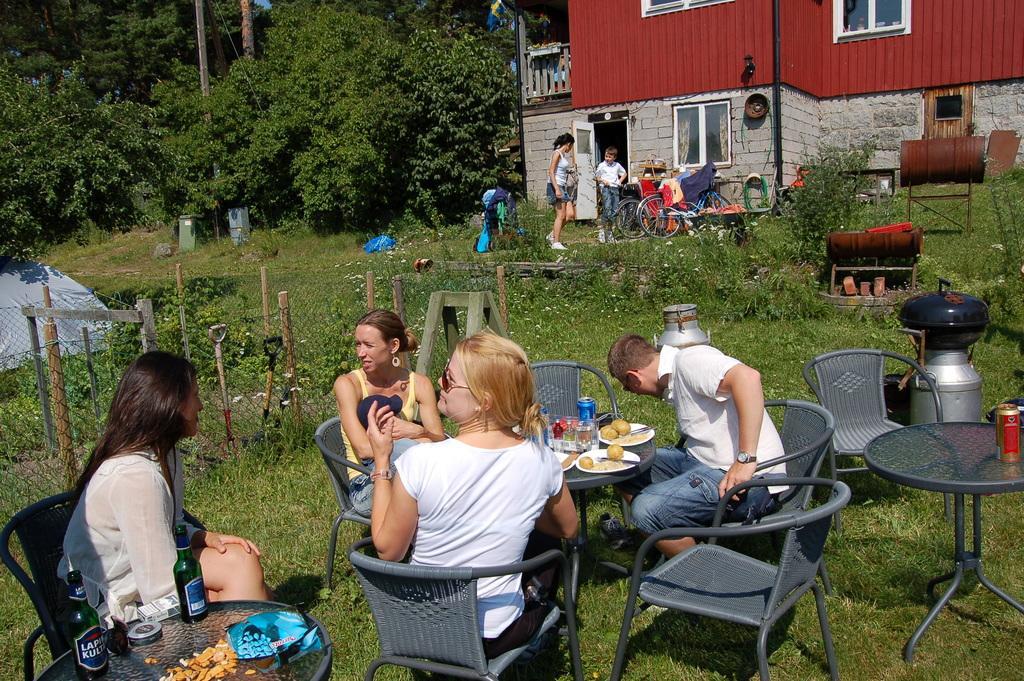Could you give a brief overview of what you see in this image? This picture is clicked outside the city. Here, we see many people sitting on chair and in front of them, we see table on which plate containing food,spoon, coke bottle, alcohol bottle and some snacks are placed. Behind them, we see bicycles and beside that, we see a building which is red in color and beside that, we see many trees. On the left corner of the picture, we see a tent which is grey in color. 